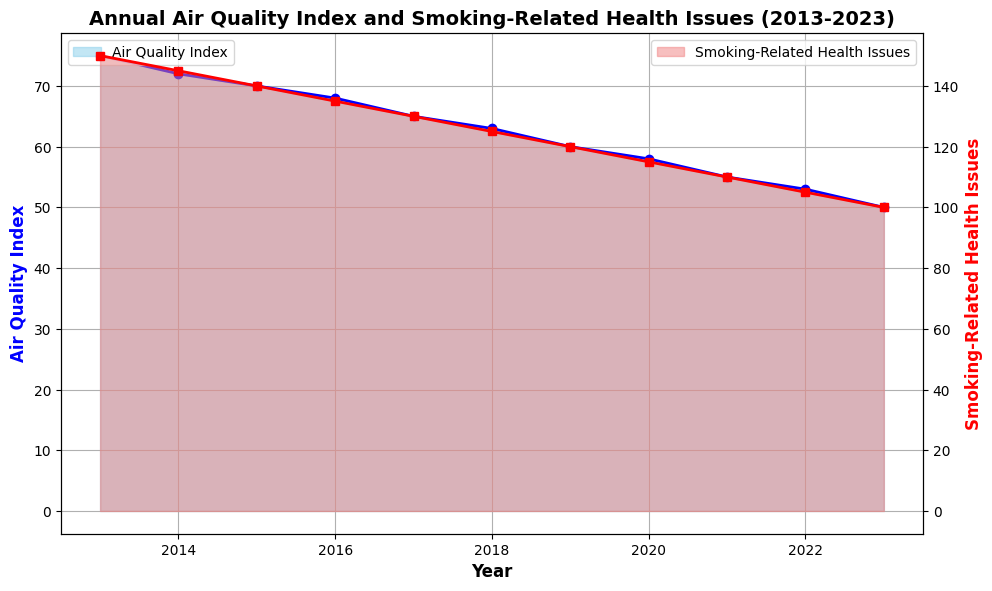What's the trend in the Air Quality Index from 2013 to 2023? By observing the blue shaded area and the blue line, we notice a consistent downward trend in the Air Quality Index every year. The values decrease from 75 in 2013 to 50 in 2023.
Answer: Downward trend Compare the smoking-related health issues in 2015 and 2020. Which year had more incidents, and by how much? By observing the red line and the red shaded area, we see that 2015 had 140 incidents, and 2020 had 115 incidents. To find the difference: 140 - 115 = 25. So, 2015 had 25 more incidents than 2020.
Answer: 2015 had 25 more incidents During which year did the Air Quality Index first drop below 60? Checking the blue line and the corresponding years, the Air Quality Index first drops below 60 in 2019. The value in 2019 is 60, and in 2020 it is 58.
Answer: 2020 What is the average Air Quality Index from 2013 to 2023? Add up all the Air Quality Index values from 2013 to 2023 and divide by the number of years: (75 + 72 + 70 + 68 + 65 + 63 + 60 + 58 + 55 + 53 + 50) / 11 = 64.36.
Answer: 64.36 How much did the smoking-related health issues decrease from 2013 to 2023? The value in 2013 is 150 and in 2023 is 100. To find the decrease: 150 - 100 = 50.
Answer: 50 Which year shows the highest Air Quality Index, and what is the corresponding smoking-related health issue count? The highest Air Quality Index is in 2013 at 75. The corresponding smoking-related health issues count for that year is 150.
Answer: 2013, 150 incidents What is the difference in Air Quality Index between the years 2018 and 2021? The Air Quality Index in 2018 is 63 and in 2021 is 55. To find the difference: 63 - 55 = 8.
Answer: 8 In what year did the smoking-related health issues drop below 130 for the first time? Observing the red line and shaded area, the incidents drop below 130 for the first time in 2017. The value for 2017 is 130 and for 2018 is 125.
Answer: 2018 